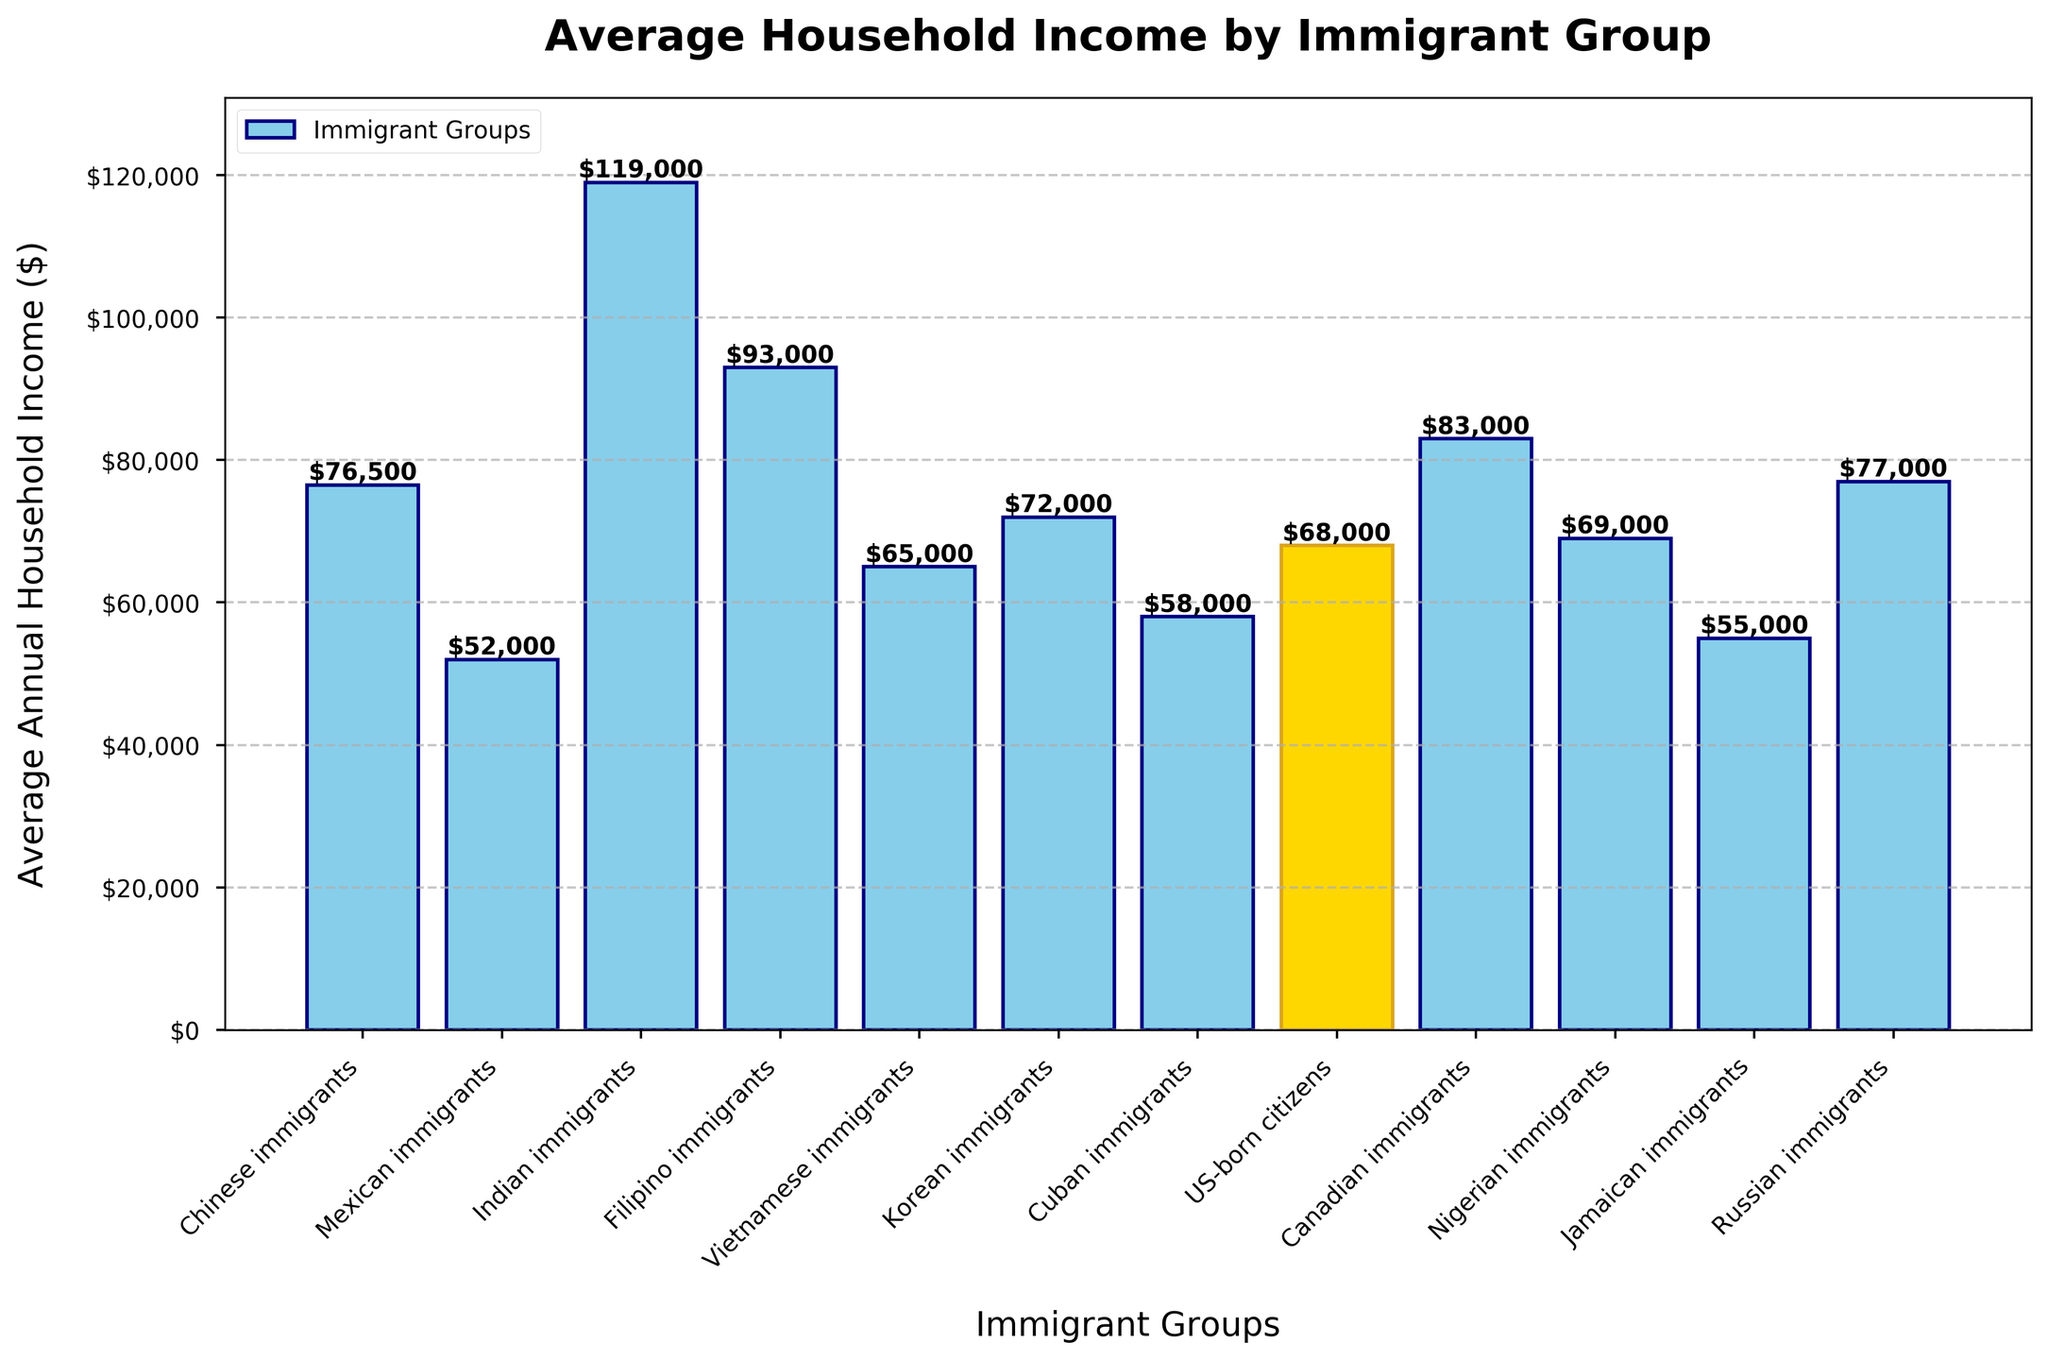How much higher is the average household income of Chinese immigrants compared to Mexican immigrants? To find how much higher the average household income of Chinese immigrants ($76,500) is compared to that of Mexican immigrants ($52,000), subtract the income of Mexican immigrants from the income of Chinese immigrants: $76,500 - $52,000 = $24,500
Answer: $24,500 Which immigrant group has the highest average annual household income? To find the group with the highest average annual household income, look for the tallest bar in the bar chart. The tallest bar corresponds to Indian immigrants with an income of $119,000
Answer: Indian immigrants What is the difference in average household income between Filipino immigrants and US-born citizens? To find the difference in average household income, subtract the income of US-born citizens ($68,000) from that of Filipino immigrants ($93,000): $93,000 - $68,000 = $25,000
Answer: $25,000 Which two immigrant groups have similar average household incomes, and what are those incomes? To find similar average household incomes, look for bars with nearly the same height. The incomes for Chinese immigrants ($76,500) and Russian immigrants ($77,000) are very close.
Answer: Chinese immigrants and Russian immigrants, $76,500 and $77,000 Who has a higher average household income, Vietnamese immigrants or Nigerian immigrants? Compare the heights of the bars for Vietnamese immigrants ($65,000) and Nigerian immigrants ($69,000). Nigerian immigrants have a higher income.
Answer: Nigerian immigrants Which group has the lowest average annual household income, and how much is it? To find the group with the lowest average annual household income, look for the shortest bar in the bar chart. The shortest bar corresponds to Mexican immigrants with an income of $52,000
Answer: Mexican immigrants, $52,000 What is the combined average household income of Cuban and Jamaican immigrants? To find the combined average household income, add the incomes of Cuban immigrants ($58,000) and Jamaican immigrants ($55,000): $58,000 + $55,000 = $113,000
Answer: $113,000 How many immigrant groups have a higher average household income than US-born citizens? US-born citizens have an average household income of $68,000. Count the number of bars that are higher than this amount: Chinese, Indian, Filipino, Korean, Russian, and Canadian immigrants, totaling 6 groups.
Answer: 6 groups What is the average income of the top three highest-earning immigrant groups? The top three highest-earning groups are Indian ($119,000), Filipino ($93,000), and Canadian ($83,000). Calculate the average by summing these incomes and dividing by three: ($119,000 + $93,000 + $83,000) / 3 = $98,333.33
Answer: $98,333.33 What color is used to highlight the bar for US-born citizens, and why might this color have been chosen? The bar for US-born citizens is highlighted in gold. This color is typically used to make this bar stand out from the others, emphasizing US-born citizens as a benchmark for comparison.
Answer: Gold 